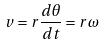Convert formula to latex. <formula><loc_0><loc_0><loc_500><loc_500>v = r \frac { d \theta } { d t } = r \omega</formula> 